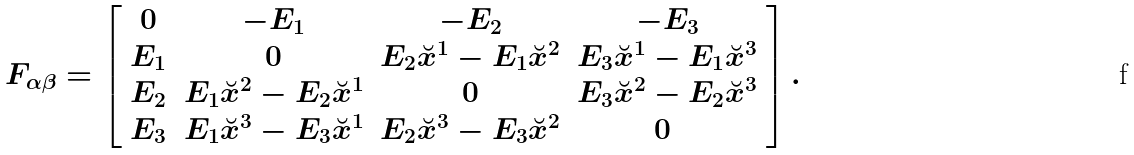<formula> <loc_0><loc_0><loc_500><loc_500>F _ { \alpha \beta } = \left [ \begin{array} { c c c c } 0 & - E _ { 1 } & - E _ { 2 } & - E _ { 3 } \\ E _ { 1 } & 0 & E _ { 2 } \breve { x } ^ { 1 } - E _ { 1 } \breve { x } ^ { 2 } & E _ { 3 } \breve { x } ^ { 1 } - E _ { 1 } \breve { x } ^ { 3 } \\ E _ { 2 } & E _ { 1 } \breve { x } ^ { 2 } - E _ { 2 } \breve { x } ^ { 1 } & 0 & E _ { 3 } \breve { x } ^ { 2 } - E _ { 2 } \breve { x } ^ { 3 } \\ E _ { 3 } & E _ { 1 } \breve { x } ^ { 3 } - E _ { 3 } \breve { x } ^ { 1 } & E _ { 2 } \breve { x } ^ { 3 } - E _ { 3 } \breve { x } ^ { 2 } & 0 \ \end{array} \right ] .</formula> 